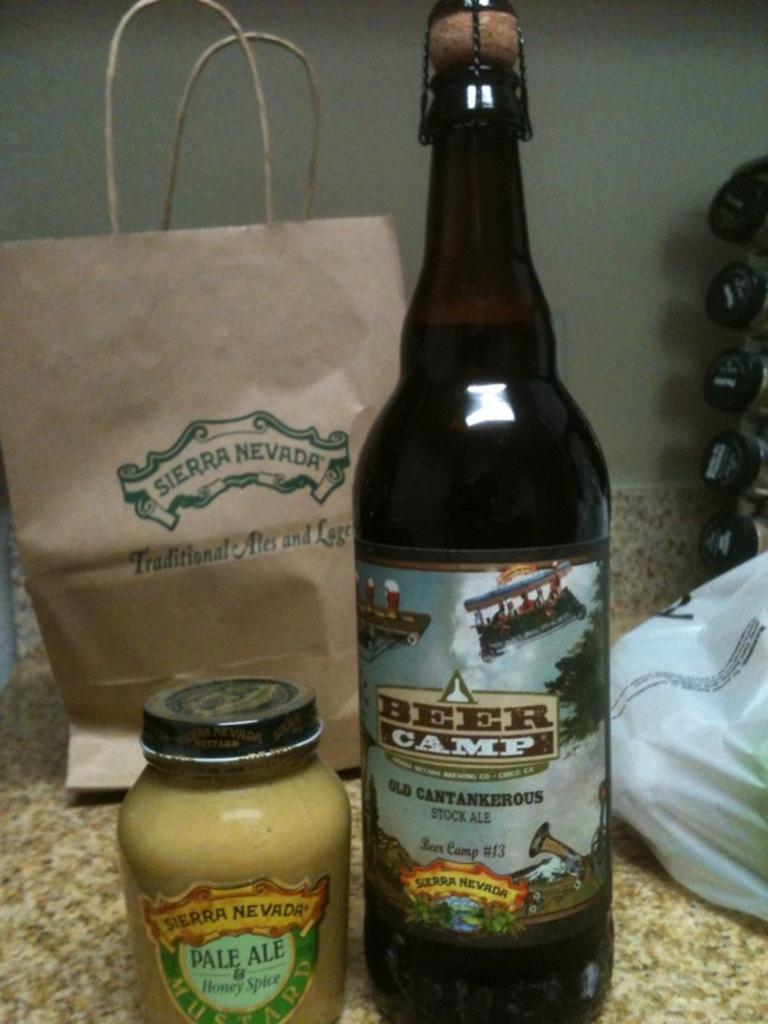<image>
Create a compact narrative representing the image presented. A bottle of Beer Camp beer is next to a jar of honey spice sauce. 